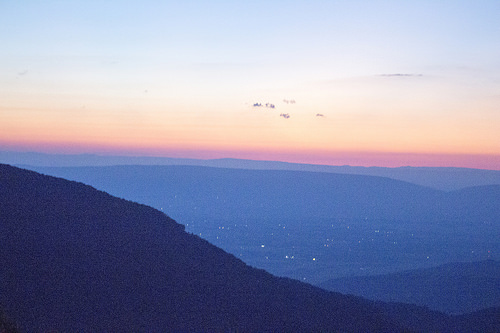<image>
Is the sky behind the mountain? No. The sky is not behind the mountain. From this viewpoint, the sky appears to be positioned elsewhere in the scene. 